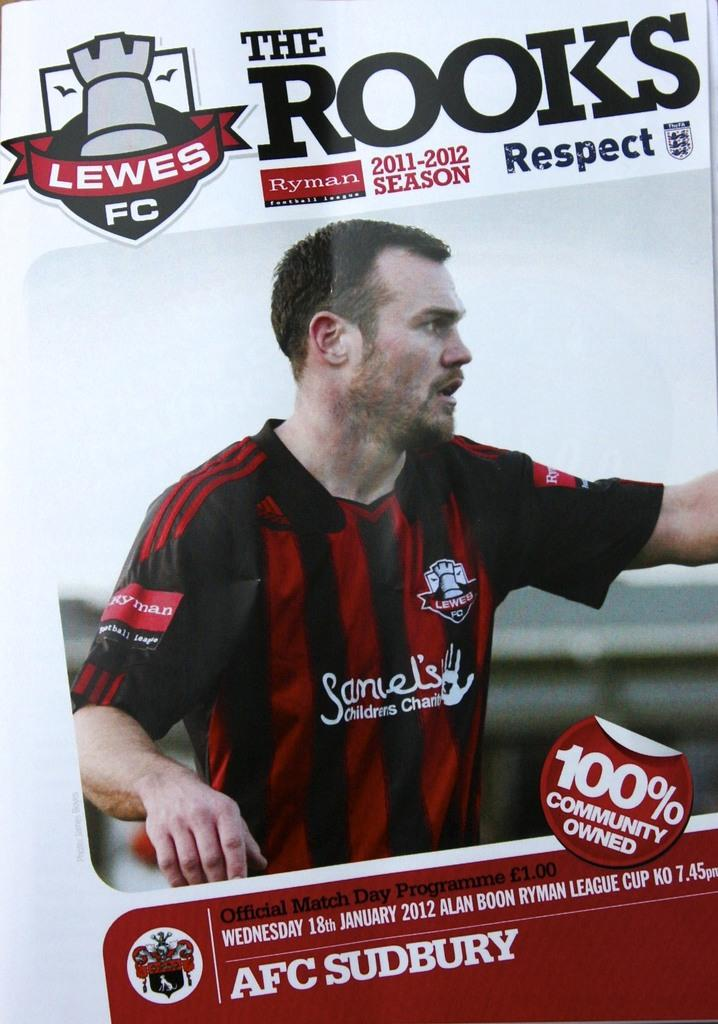<image>
Give a short and clear explanation of the subsequent image. an advertisement for AFC sudbury, which is 100% community owned 